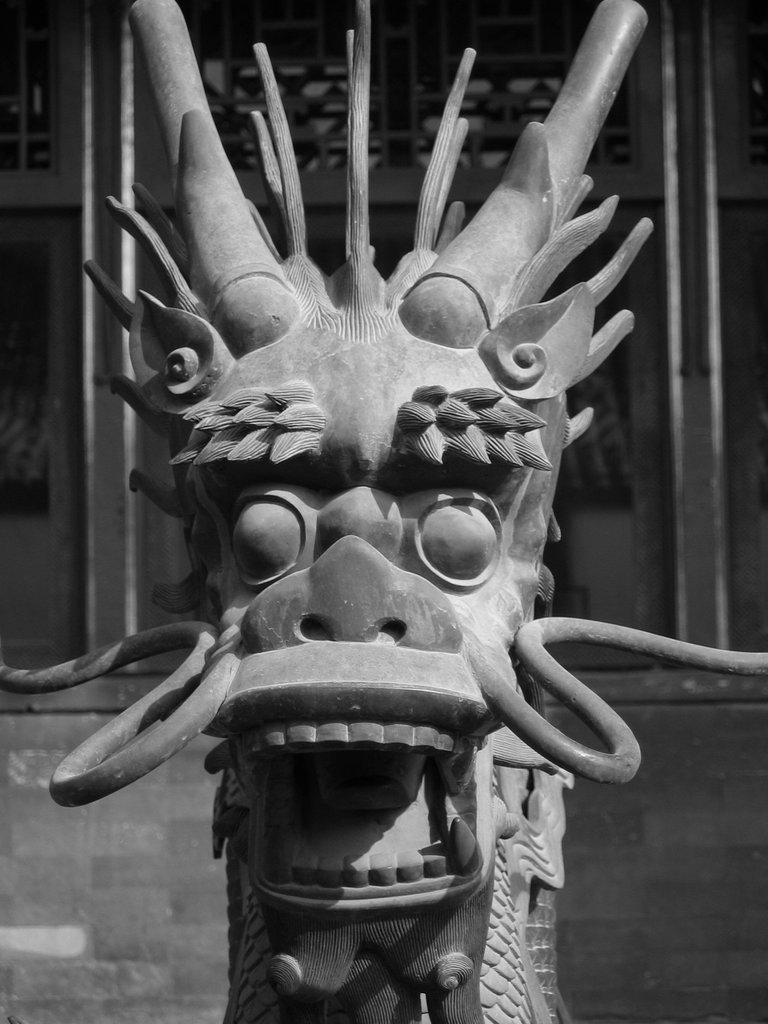What is the color scheme of the image? The image is black and white. What is the main subject in the image? There is a sculpture in the image. What can be seen in the background of the image? There is a building in the background of the image. What type of quiver is being used by the sculpture in the image? There is no quiver present in the image, as it features a sculpture and a building in a black and white color scheme. 